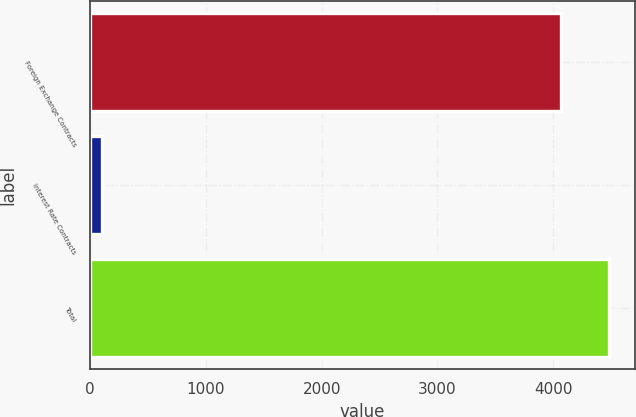Convert chart to OTSL. <chart><loc_0><loc_0><loc_500><loc_500><bar_chart><fcel>Foreign Exchange Contracts<fcel>Interest Rate Contracts<fcel>Total<nl><fcel>4072<fcel>101.3<fcel>4479.2<nl></chart> 